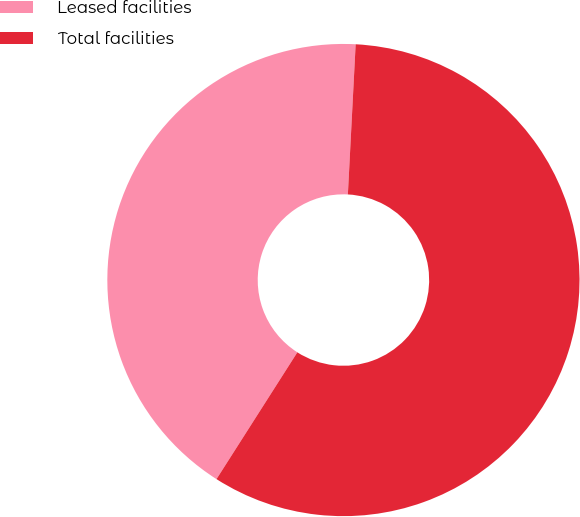<chart> <loc_0><loc_0><loc_500><loc_500><pie_chart><fcel>Leased facilities<fcel>Total facilities<nl><fcel>41.79%<fcel>58.21%<nl></chart> 